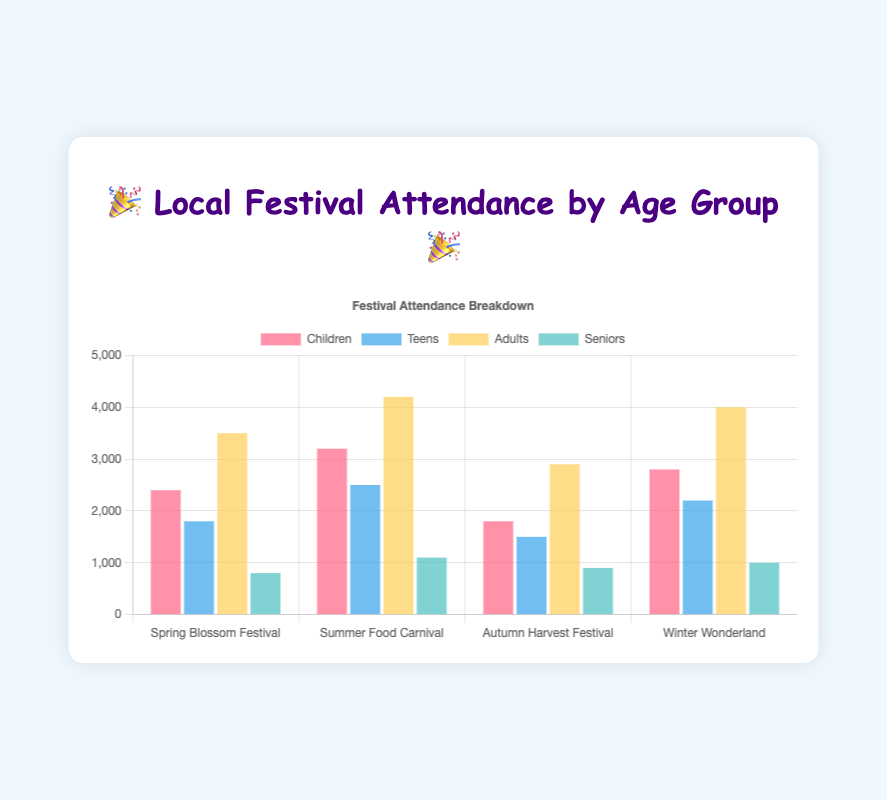Which age group had the highest attendance at the Summer Food Carnival? Look at the bars for the Summer Food Carnival and compare their heights to determine which is tallest.
Answer: Adults Which festival had the lowest attendance among seniors? Compare the heights of the bars for the Seniors category across all festivals to find the shortest one.
Answer: Spring Blossom Festival How many more children attended the Summer Food Carnival compared to the Autumn Harvest Festival? Subtract the number of children who attended the Autumn Harvest Festival (1800) from the number who attended the Summer Food Carnival (3200).
Answer: 1400 What is the total attendance at the Spring Blossom Festival? Sum the attendance numbers for all age groups at the Spring Blossom Festival: 2400 (Children) + 1800 (Teens) + 3500 (Adults) + 800 (Seniors).
Answer: 8500 Which festival had the most even distribution of attendance across all age groups (least variation)? Compare the differences between the highest and lowest attendance numbers among age groups for each festival to see which is smallest.
Answer: Winter Wonderland How many more adults attended the Winter Wonderland compared to the Spring Blossom Festival? Subtract the number of adults who attended the Spring Blossom Festival (3500) from the number who attended the Winter Wonderland (4000).
Answer: 500 Which festival saw a higher attendance from teens compared to children? Compare the heights of the bars representing Teens and Children within each festival to see where the Teens' bar is taller.
Answer: None What is the average attendance of seniors across all festivals? Sum the attendance numbers for Seniors across all festivals (800 + 1100 + 900 + 1000) and divide by the number of festivals (4).
Answer: 950 For which festival is the gap between the largest and smallest age group attendance the greatest? Calculate the difference between the highest and lowest attendance within each festival and compare them to find the greatest gap.
Answer: Summer Food Carnival What is the percentage of adult attendees at the Autumn Harvest Festival out of the total attendees for that festival? Divide the number of adults at the Autumn Harvest Festival (2900) by the total number of attendees at that festival (2900 + 1800 + 1500 + 900) and multiply by 100 for the percentage.
Answer: 45.31% 